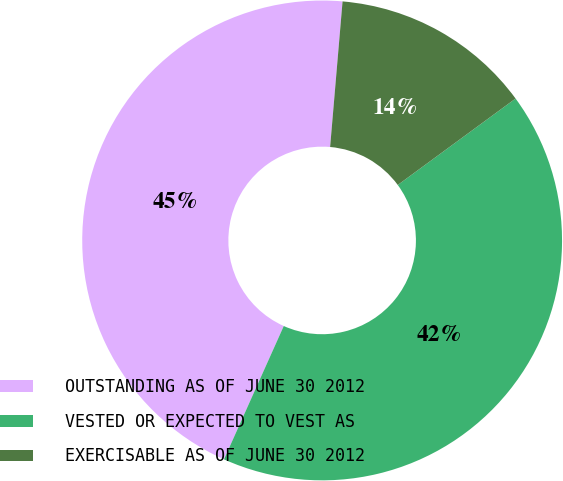<chart> <loc_0><loc_0><loc_500><loc_500><pie_chart><fcel>OUTSTANDING AS OF JUNE 30 2012<fcel>VESTED OR EXPECTED TO VEST AS<fcel>EXERCISABLE AS OF JUNE 30 2012<nl><fcel>44.65%<fcel>41.78%<fcel>13.57%<nl></chart> 